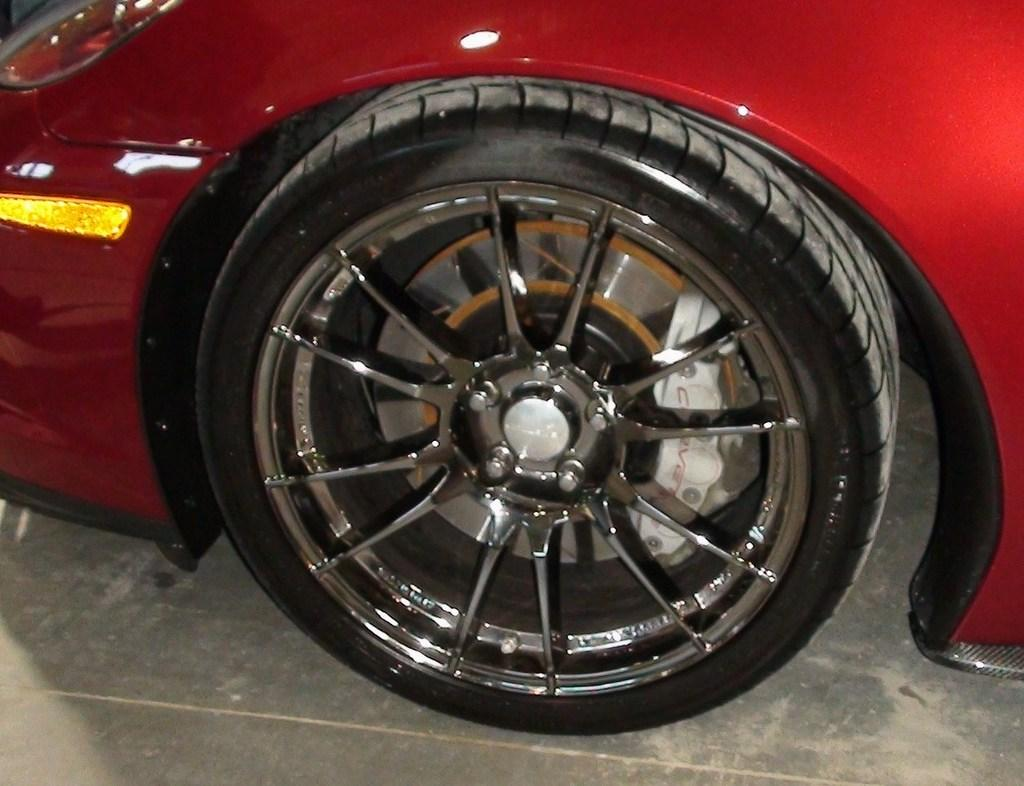What color is the car in the image? The car in the image is red. What part of the car can be seen in the image? The car has a wheel visible in the image. What type of surface is at the bottom of the image? There is pavement at the bottom of the image. Can you see any butter on the car in the image? There is no butter present in the image. Is there a farm visible in the background of the image? There is no farm visible in the image; it only features a red car with a visible wheel on pavement. 